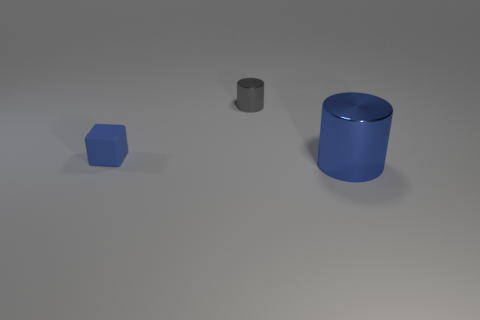Add 3 blue blocks. How many objects exist? 6 Subtract all blue cylinders. How many cylinders are left? 1 Subtract 1 blocks. How many blocks are left? 0 Subtract all tiny blue matte objects. Subtract all large purple rubber objects. How many objects are left? 2 Add 2 blue rubber things. How many blue rubber things are left? 3 Add 3 blue objects. How many blue objects exist? 5 Subtract 0 purple cylinders. How many objects are left? 3 Subtract all blocks. How many objects are left? 2 Subtract all green blocks. Subtract all yellow balls. How many blocks are left? 1 Subtract all green balls. How many green cylinders are left? 0 